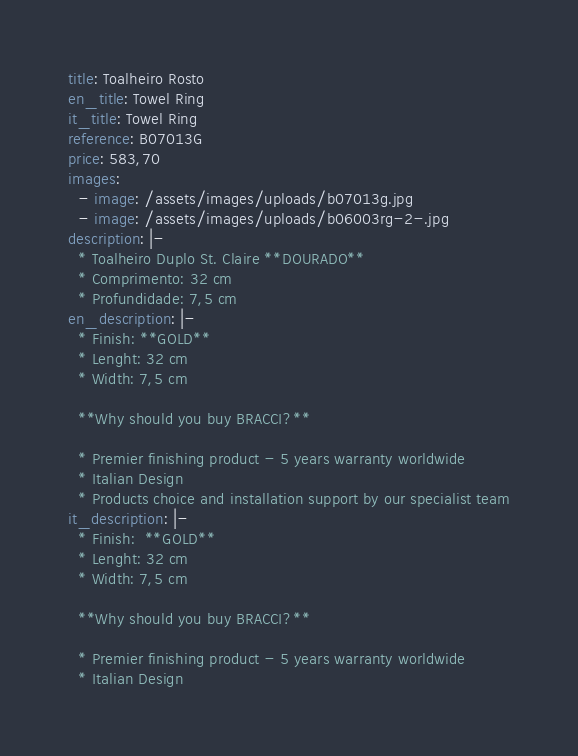<code> <loc_0><loc_0><loc_500><loc_500><_YAML_>title: Toalheiro Rosto
en_title: Towel Ring
it_title: Towel Ring
reference: B07013G
price: 583,70
images:
  - image: /assets/images/uploads/b07013g.jpg
  - image: /assets/images/uploads/b06003rg-2-.jpg
description: |-
  * Toalheiro Duplo St. Claire **DOURADO**
  * Comprimento: 32 cm
  * Profundidade: 7,5 cm
en_description: |-
  * Finish: **GOLD**
  * Lenght: 32 cm
  * Width: 7,5 cm

  **Why should you buy BRACCI?**

  * Premier finishing product - 5 years warranty worldwide
  * Italian Design
  * Products choice and installation support by our specialist team
it_description: |-
  * Finish:  **GOLD**
  * Lenght: 32 cm
  * Width: 7,5 cm

  **Why should you buy BRACCI?**

  * Premier finishing product - 5 years warranty worldwide
  * Italian Design</code> 